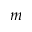<formula> <loc_0><loc_0><loc_500><loc_500>m</formula> 